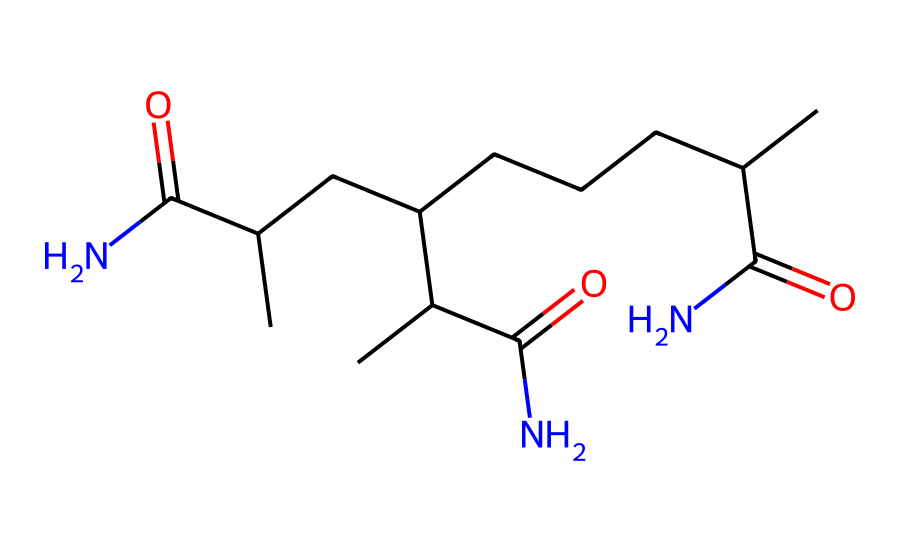What is the name of this chemical? The SMILES representation indicates that the chemical is polyacrylamide, which consists of acrylamide monomers linked through amide functional groups.
Answer: polyacrylamide How many carbon atoms are in this structure? By analyzing the SMILES, we can count the number of 'C' characters. There are 15 carbon atoms present in total.
Answer: 15 What type of bonding is primarily present in polyacrylamide? The structure shows that polyacrylamide has significant covalent bonding, especially between the carbon and nitrogen atoms in the amide groups.
Answer: covalent Does this chemical contain any nitrogen atoms? A review of the SMILES structure shows that there are amide functional groups, which include nitrogen (N) atoms.
Answer: yes What applications is polyacrylamide commonly used for? Polyacrylamide is frequently utilized in soil stabilization and construction projects, particularly in non-Newtonian fluid applications because of its ability to increase viscosity.
Answer: soil stabilization How does polyacrylamide behave when stress is applied? It exhibits non-Newtonian behavior, meaning its viscosity changes under applied stress — shearing causes it to thin out rather than maintain a constant viscosity.
Answer: thins out What is the role of polyacrylamide in non-Newtonian fluids? In non-Newtonian fluids, polyacrylamide modifies the fluid's viscosity to improve its performance under varying flow conditions in soil stabilization.
Answer: modifies viscosity 